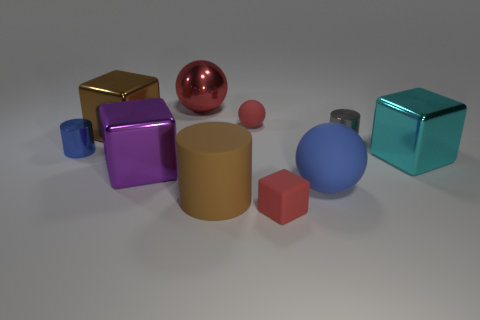How many cyan things have the same shape as the large brown metal object?
Ensure brevity in your answer.  1. What is the gray object made of?
Provide a succinct answer. Metal. Is the big blue matte object the same shape as the small gray thing?
Your response must be concise. No. Is there a big cyan thing that has the same material as the blue sphere?
Give a very brief answer. No. There is a ball that is both behind the tiny blue shiny thing and to the right of the big shiny sphere; what is its color?
Ensure brevity in your answer.  Red. There is a cube in front of the large brown rubber cylinder; what is its material?
Provide a short and direct response. Rubber. Are there any small brown metal things that have the same shape as the small gray shiny thing?
Offer a terse response. No. What number of other objects are there of the same shape as the large brown metallic thing?
Offer a terse response. 3. There is a red metallic thing; does it have the same shape as the big matte object that is in front of the big matte sphere?
Your response must be concise. No. Is there any other thing that is made of the same material as the large blue thing?
Make the answer very short. Yes. 